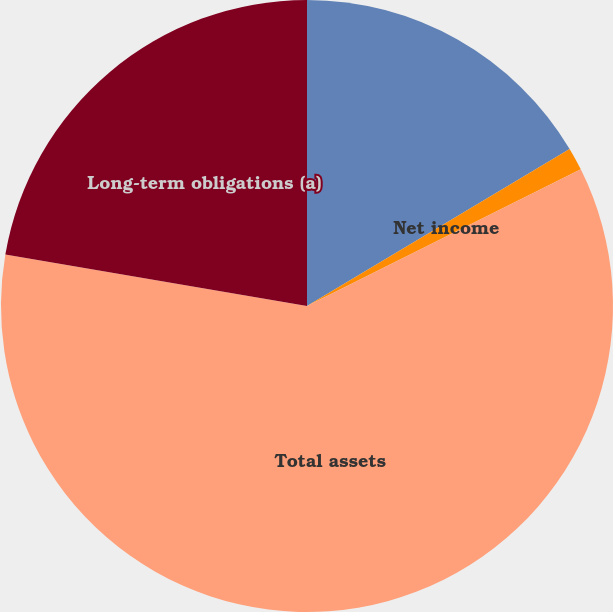Convert chart. <chart><loc_0><loc_0><loc_500><loc_500><pie_chart><fcel>Operating revenues<fcel>Net income<fcel>Total assets<fcel>Long-term obligations (a)<nl><fcel>16.42%<fcel>1.21%<fcel>60.05%<fcel>22.31%<nl></chart> 